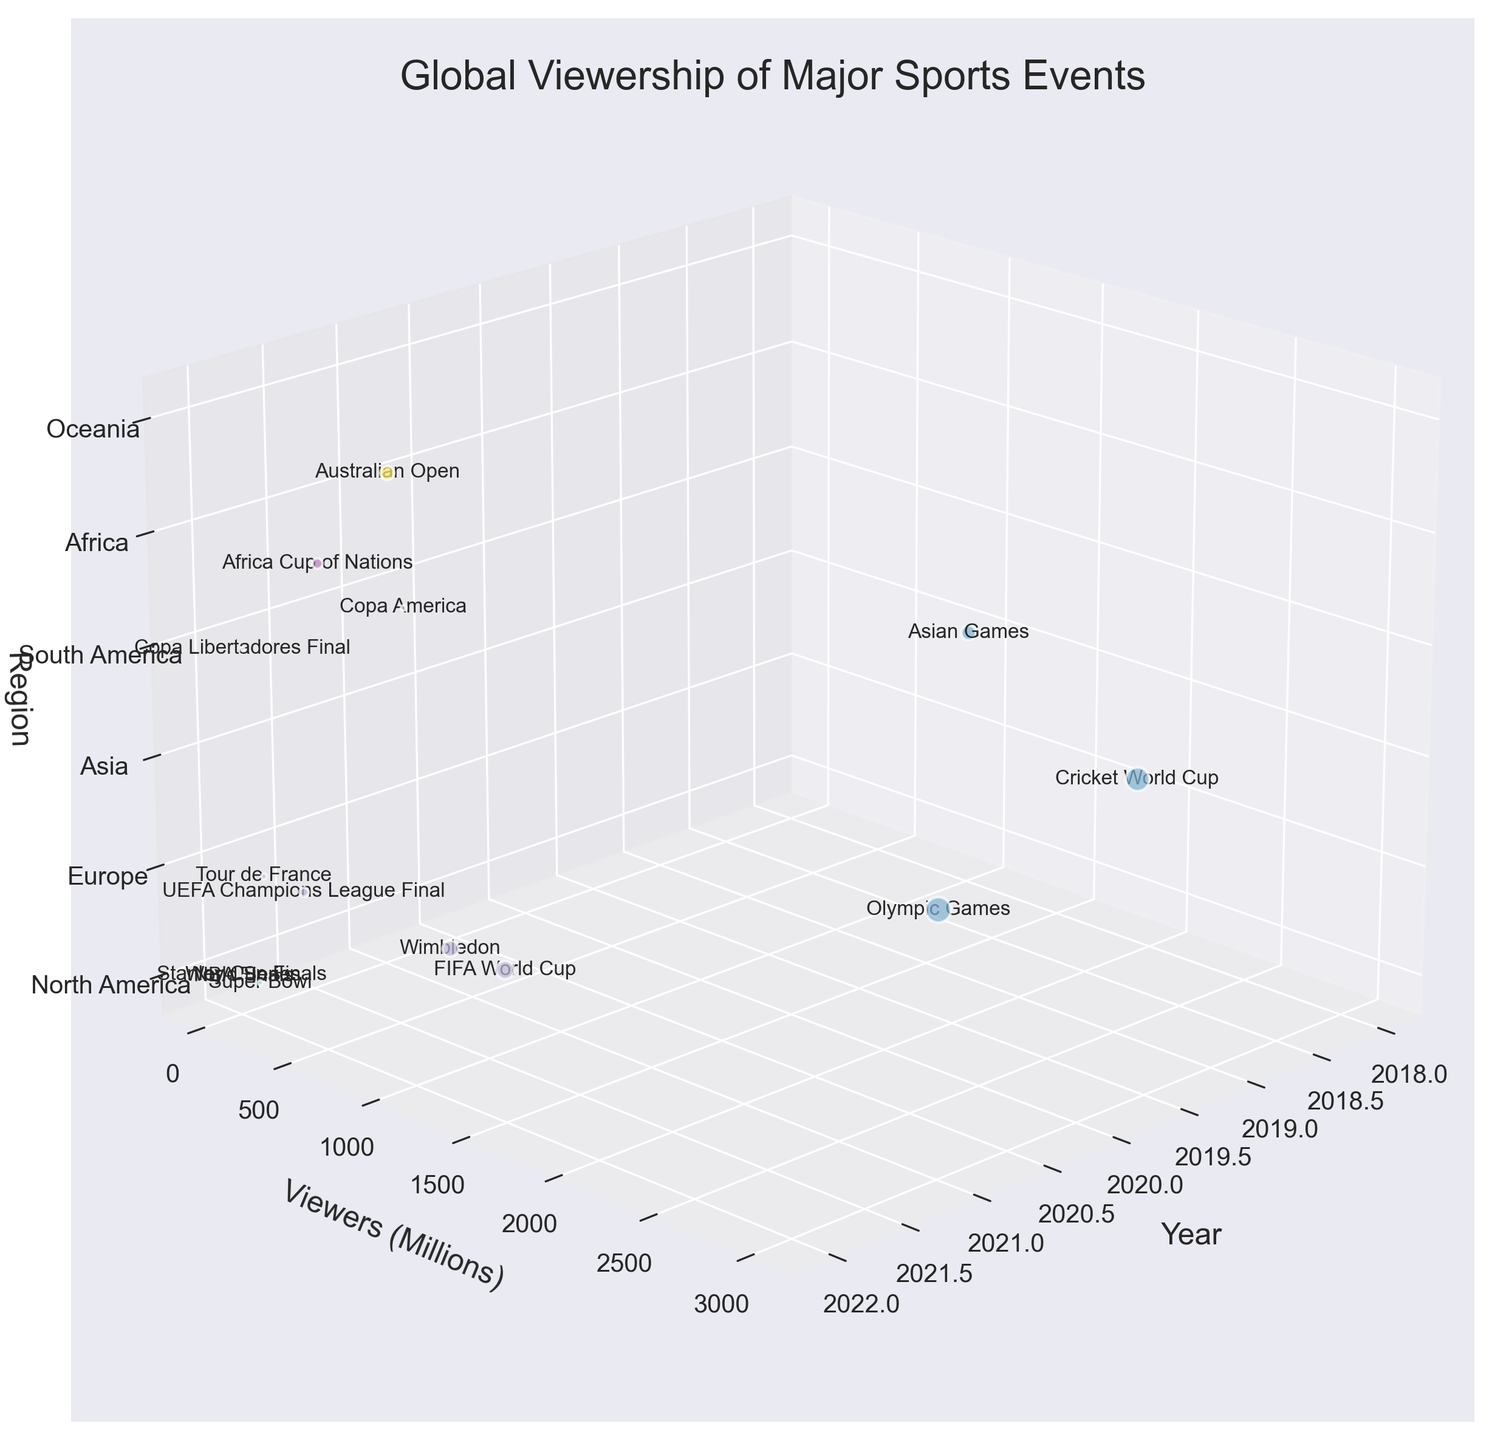What is the title of the figure? The title is usually displayed at the top of the figure. It provides a summary of what the figure represents.
Answer: "Global Viewership of Major Sports Events" Which region had the highest viewership for a single event? Check the axis representing 'Viewers (Millions)' and identify the bubble with the highest value. The 'FIFA World Cup' in Europe in 2022 stands out as the highest.
Answer: Europe How many sports events are represented for the year 2022? Count the number of unique bubbles corresponding to the year 2022 along the 'Year' axis.
Answer: 10 Which event had more viewers in 2022, the Super Bowl or the UEFA Champions League Final? Locate both events on the 'Year' axis at 2022, and compare their positions on the 'Viewers (Millions)' axis.
Answer: UEFA Champions League Final By how much did the viewership for the Cricket World Cup in 2019 exceed that of the Super Bowl in 2022? Find both events on the 'Viewers (Millions)' axis, subtract the smaller value (112 million for the Super Bowl) from the larger value (2600 million for the Cricket World Cup).
Answer: 2488 million Which region is represented by the color associated with the UEFA Champions League Final? Identify the color of the bubble for the UEFA Champions League Final and match it to the region in the legend or axis labels.
Answer: Europe Which event saw more viewers in Asia, the Olympic Games in 2021 or the Cricket World Cup in 2019? Locate both events on the 'Viewers (Millions)' axis and region axis, and compare their values.
Answer: Cricket World Cup How does the viewership of the NBA Finals in 2022 compare to the NHL (Stanley Cup Finals) in 2022? Locate both events on the 'Viewers (Millions)' axis for 2022 and compare their values.
Answer: NBA Finals had more viewers What is the total viewership for sports events held in Europe in 2022? Sum the viewers (millions) for all events in Europe in 2022: UEFA Champions League Final (380) + Wimbledon (1200) + Tour de France (150) = 1730 million.
Answer: 1730 million What is the range of viewership values for events in North America in 2022? Identify the minimum and maximum viewership values for events in North America in 2022: Super Bowl (112 million) and Stanley Cup Finals (5 million). The range is 112 - 5 = 107 million.
Answer: 107 million 